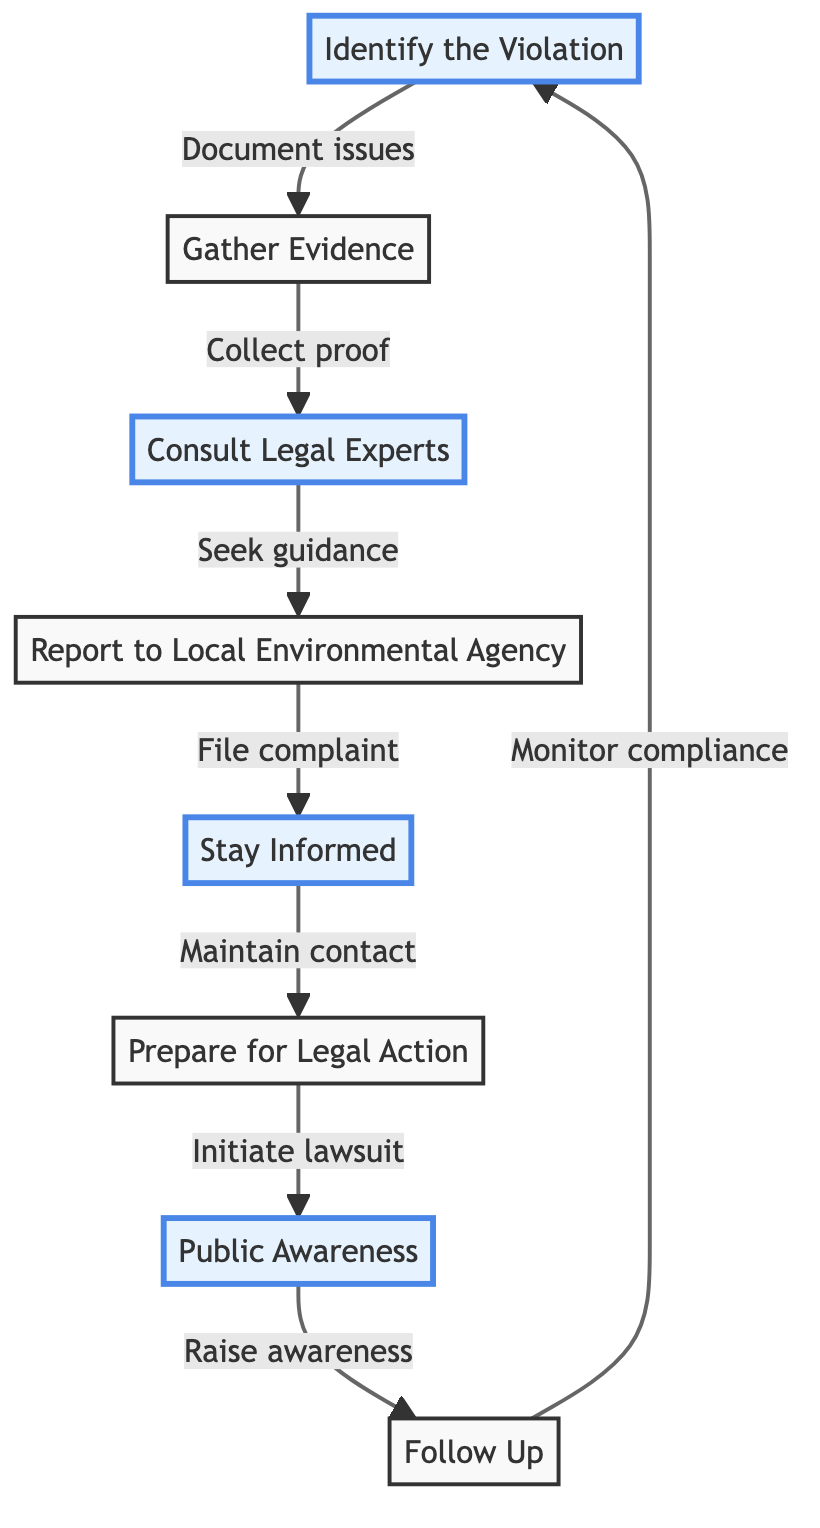What is the first step in the reporting process? The diagram indicates that the first step is "Identify the Violation," which involves recognizing and documenting the environmental issues.
Answer: Identify the Violation How many total nodes are present in the diagram? Counting the distinct steps outlined in the diagram, we have eight nodes in total, which are each represented as a unique step.
Answer: 8 What action follows "Gather Evidence"? The diagram shows that after "Gather Evidence," the next step is to "Consult Legal Experts." This is the immediate action that follows gathering proof.
Answer: Consult Legal Experts Which step is directly followed by "Stay Informed"? The step that comes directly before "Stay Informed" is "Report to Local Environmental Agency," indicating that you should file a complaint before staying updated.
Answer: Report to Local Environmental Agency What is the relationship between "Public Awareness" and "Follow Up"? The diagram illustrates that "Public Awareness" is followed by "Follow Up," indicating that after raising awareness, one should monitor compliance with regulations.
Answer: Follow Up How many of the steps are highlighted in the diagram? There are four highlighted steps in the diagram: "Identify the Violation," "Consult Legal Experts," "Stay Informed," and "Public Awareness."
Answer: 4 What action is taken if necessary after "Prepare for Legal Action"? The diagram indicates that if necessary, the action taken is to "Initiate lawsuit." This follows the preparation phase in the process.
Answer: Initiate lawsuit Which step emphasizes maintaining contact with legal experts? The step that emphasizes maintaining contact is "Stay Informed," which indicates ongoing communication with investigators and legal professionals.
Answer: Stay Informed What does the arrow from "Follow Up" lead back to? The diagram shows that the arrow from "Follow Up" leads back to "Identify the Violation," creating a feedback loop indicating ongoing vigilance and monitoring of the situation.
Answer: Identify the Violation 